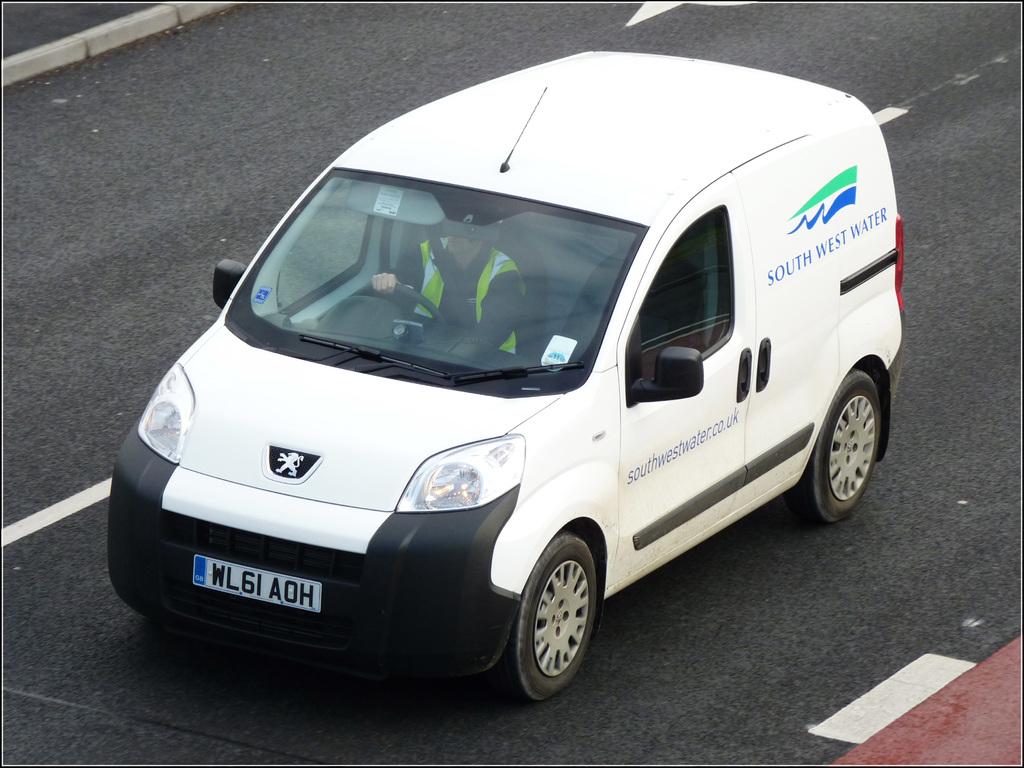What company is on the side of this van?
Provide a succinct answer. South west water. What is the license plate number of this van?
Provide a succinct answer. Wl6iaoh. 